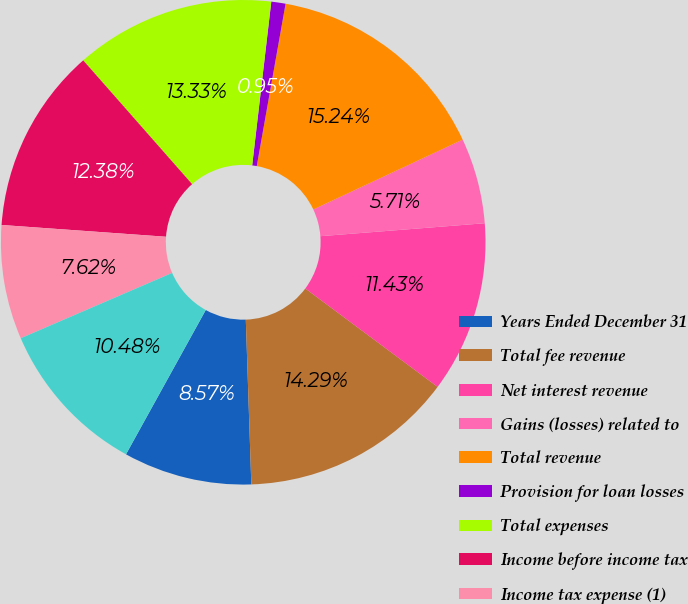<chart> <loc_0><loc_0><loc_500><loc_500><pie_chart><fcel>Years Ended December 31<fcel>Total fee revenue<fcel>Net interest revenue<fcel>Gains (losses) related to<fcel>Total revenue<fcel>Provision for loan losses<fcel>Total expenses<fcel>Income before income tax<fcel>Income tax expense (1)<fcel>Net income<nl><fcel>8.57%<fcel>14.29%<fcel>11.43%<fcel>5.71%<fcel>15.24%<fcel>0.95%<fcel>13.33%<fcel>12.38%<fcel>7.62%<fcel>10.48%<nl></chart> 